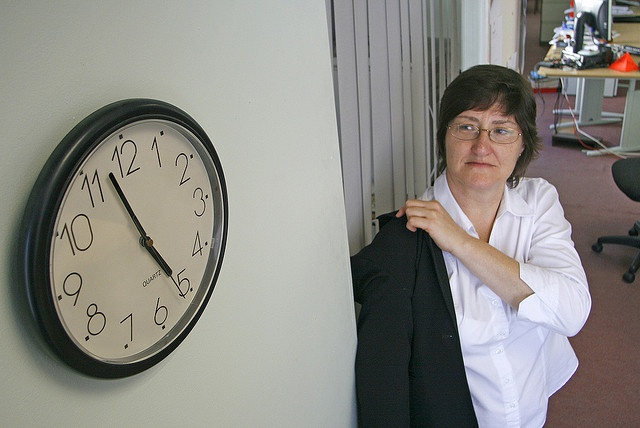Describe the objects in this image and their specific colors. I can see people in gray, black, lavender, and darkgray tones, clock in gray, darkgray, and black tones, chair in gray and black tones, and tv in gray, darkgray, black, and darkblue tones in this image. 